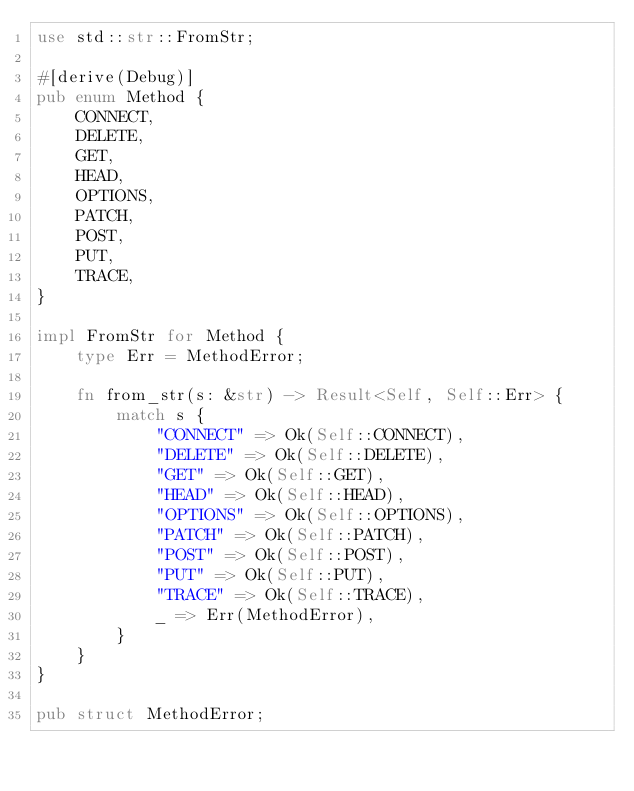Convert code to text. <code><loc_0><loc_0><loc_500><loc_500><_Rust_>use std::str::FromStr;

#[derive(Debug)]
pub enum Method {
    CONNECT,
    DELETE,
    GET,
    HEAD,
    OPTIONS,
    PATCH,
    POST,
    PUT,
    TRACE,
}

impl FromStr for Method {
    type Err = MethodError;

    fn from_str(s: &str) -> Result<Self, Self::Err> {
        match s {
            "CONNECT" => Ok(Self::CONNECT),
            "DELETE" => Ok(Self::DELETE),
            "GET" => Ok(Self::GET),
            "HEAD" => Ok(Self::HEAD),
            "OPTIONS" => Ok(Self::OPTIONS),
            "PATCH" => Ok(Self::PATCH),
            "POST" => Ok(Self::POST),
            "PUT" => Ok(Self::PUT),
            "TRACE" => Ok(Self::TRACE),
            _ => Err(MethodError),
        }
    }
}

pub struct MethodError;
</code> 